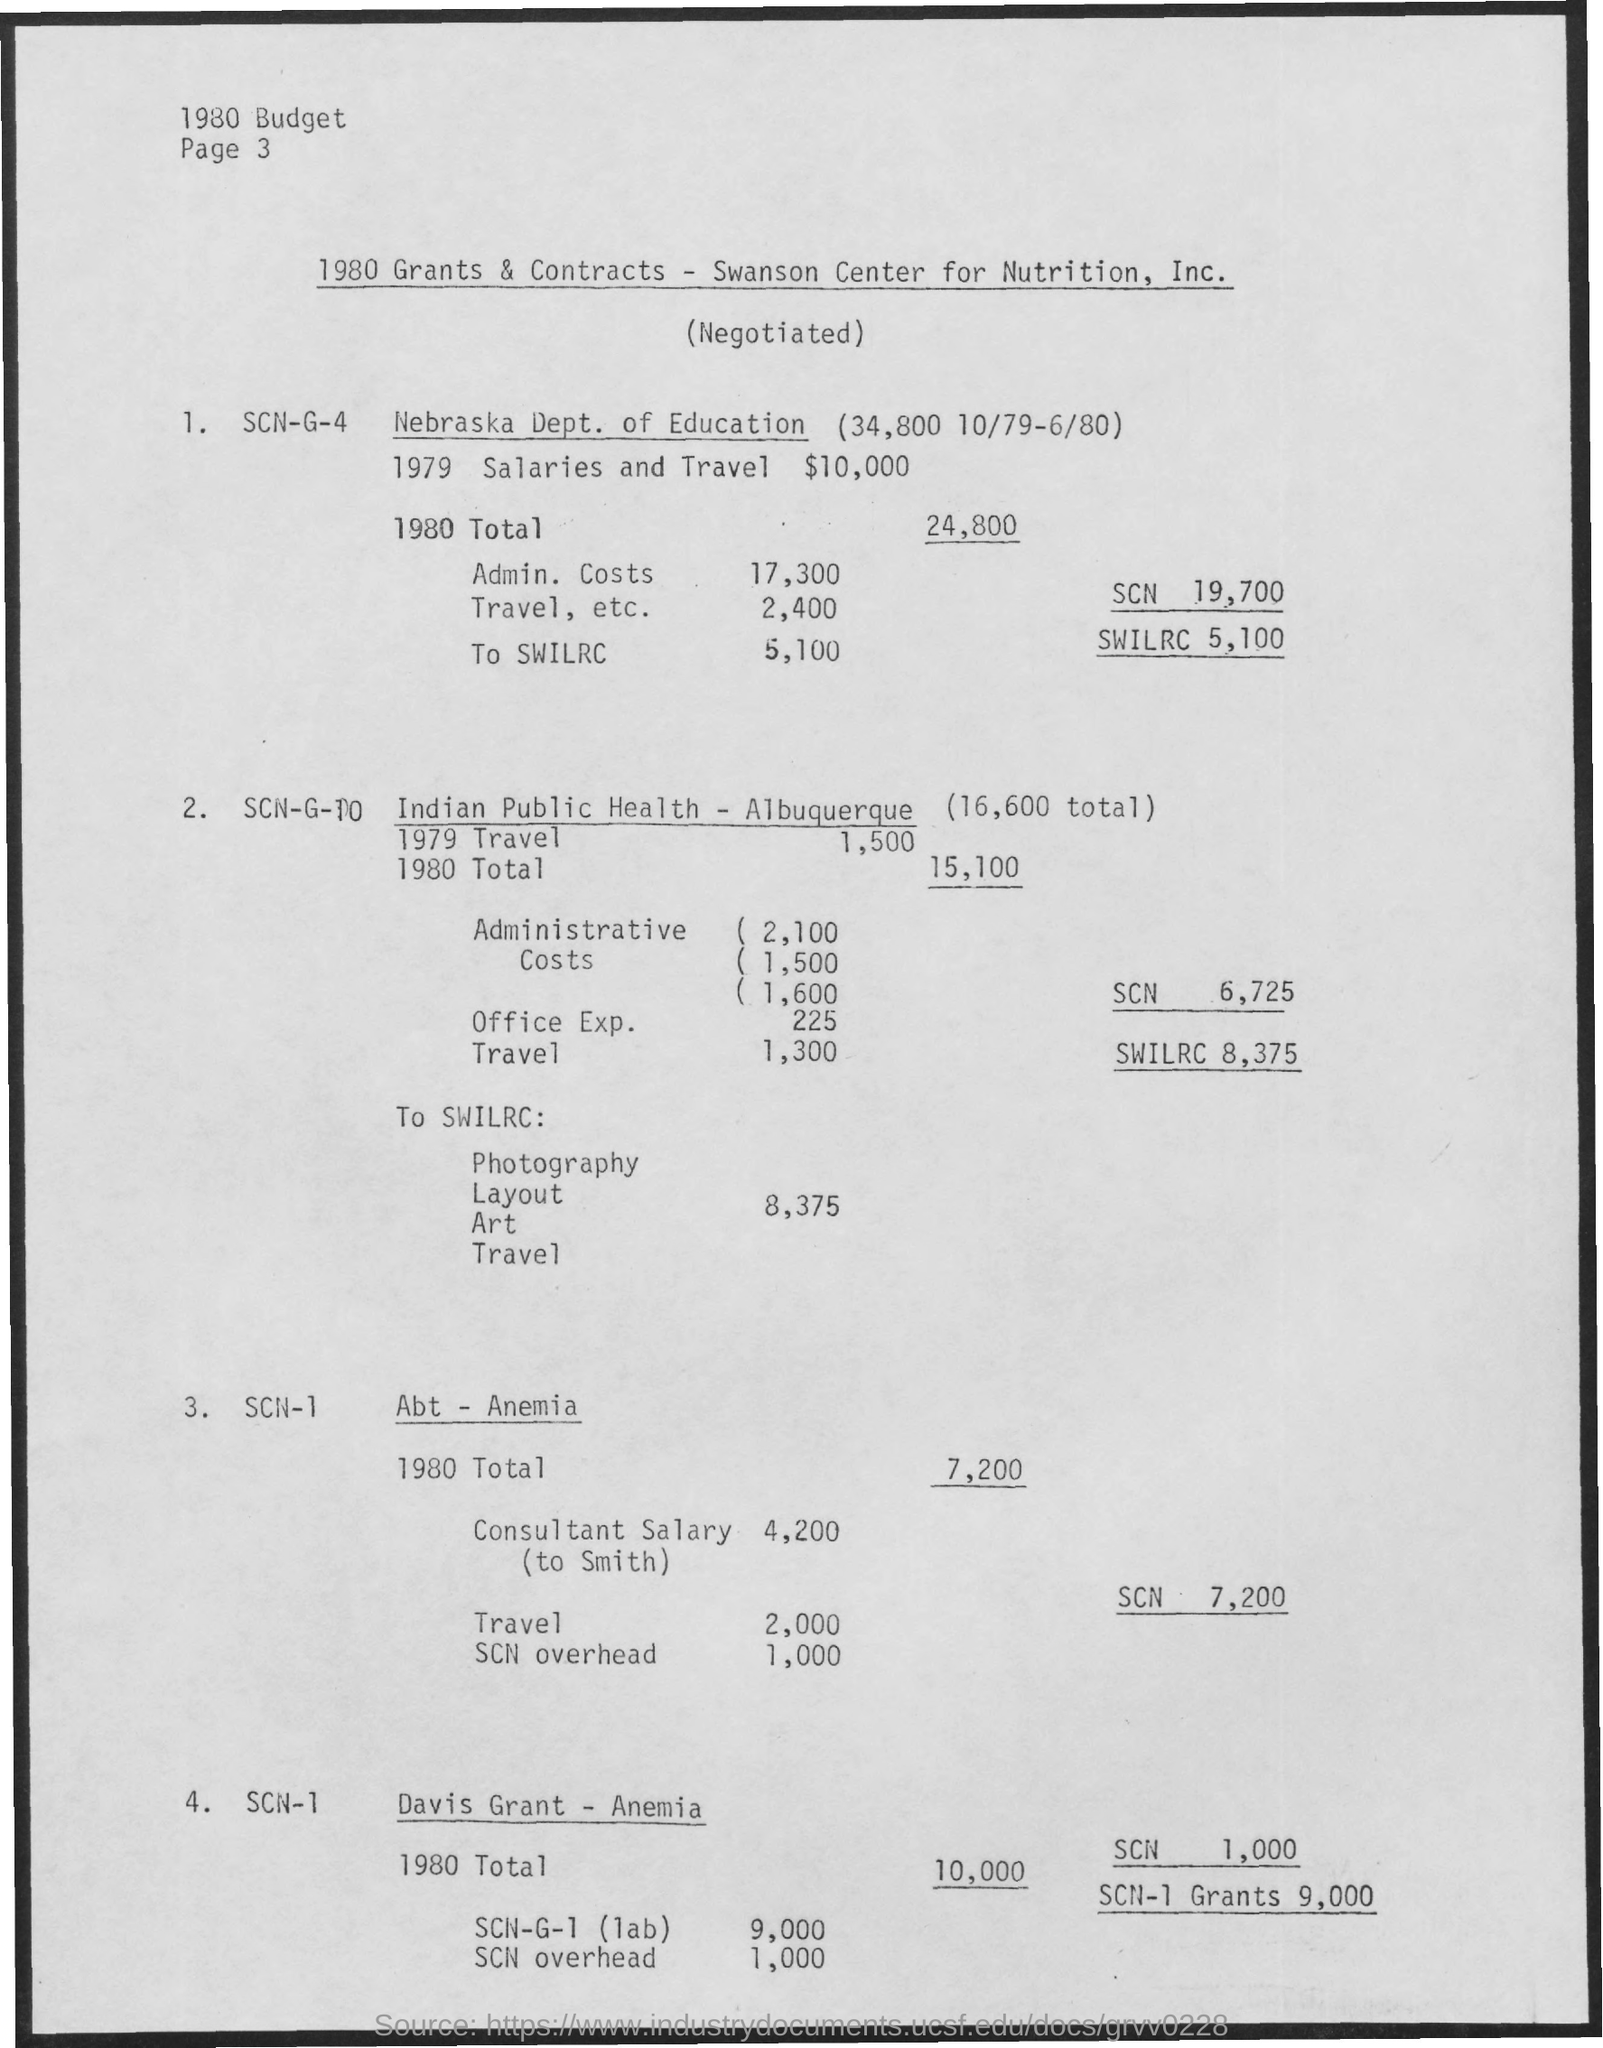According to this document, what other entities have been granted funds, and can you summarize the purpose of each grant? Besides the Nebraska Dept. of Education, grants have been allotted to the Indian Public Health in Albuquerque and for programs concerning anemia, namely 'Abt – Anemia' and 'Davis Grant – Anemia'. The Indian Public Health grant includes costs for travel, administrative fees, office expenses, photography, layout, art, and additional travel, likely associated with health-related programs or campaigns. The 'Abt – Anemia' grant appears to cover a consultant's salary and overhead costs, while the 'Davis Grant – Anemia' seems exclusively allocated to laboratory work and associated overhead expenses. 